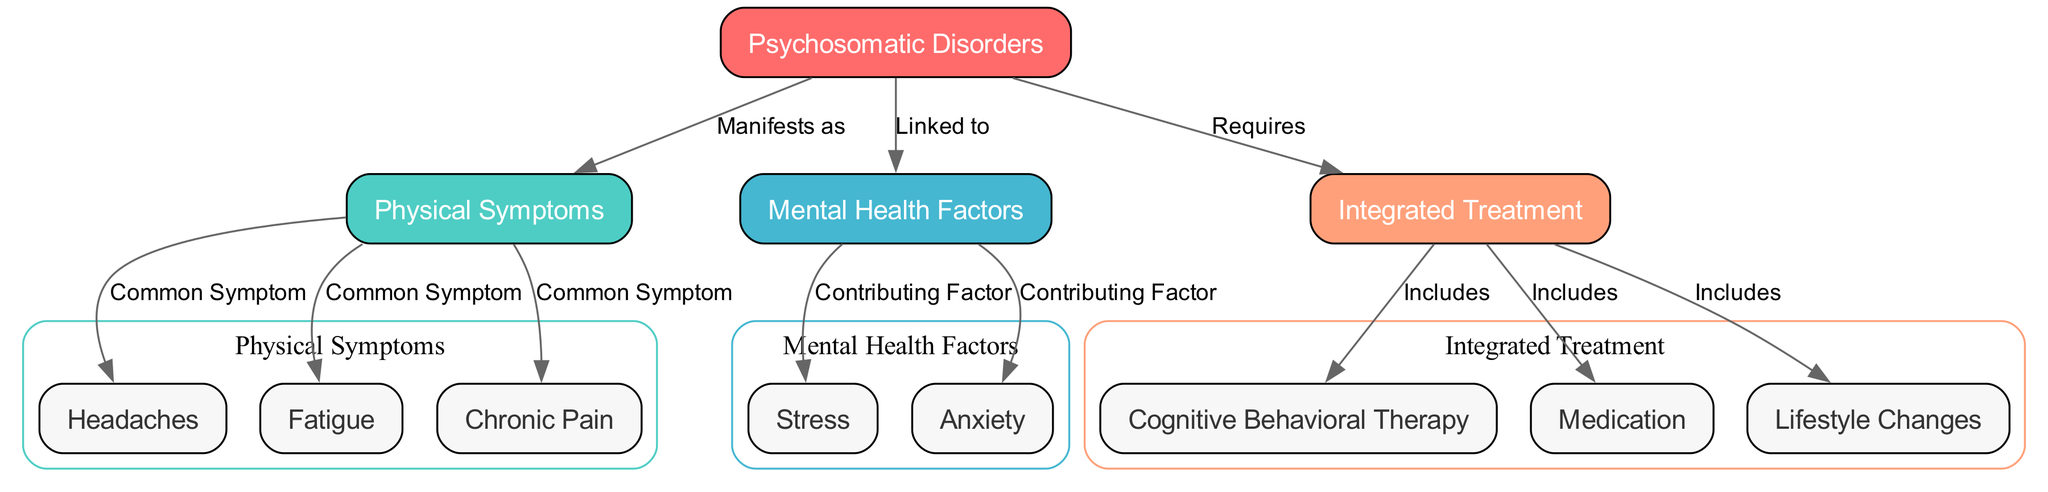What is the main topic of this diagram? The main topic of the diagram is visually represented by the first node labeled 'Psychosomatic Disorders,' indicating that all information relates back to this central theme.
Answer: Psychosomatic Disorders How many common physical symptoms are listed in the diagram? There are three specific physical symptoms listed under the Physical Symptoms cluster: 'Headaches,' 'Fatigue,' and 'Chronic Pain,' which shows the diversity of symptoms that can manifest.
Answer: 3 What are the two mental health factors that are contributing to psychosomatic disorders? The edges from the 'Mental Health Factors' node point to two specific factors: 'Stress' and 'Anxiety,' indicating these are key contributors identified in the diagram.
Answer: Stress, Anxiety Which treatment strategy is included in the integrated treatment? The 'Integrated Treatment' node includes several strategies, one of which is specifically labeled as 'Cognitive Behavioral Therapy,' indicating its role in addressing psychosomatic disorders.
Answer: Cognitive Behavioral Therapy What is the relationship between psychosomatic disorders and physical symptoms? The relationship is depicted through the edge labeled 'Manifests as,' which indicates that psychosomatic disorders manifest or appear as physical symptoms in individuals.
Answer: Manifests as What color represents mental health factors in the diagram? The mental health factors are represented with a distinct color, which is light blue, visually differentiating them from other clusters in the diagram.
Answer: Light blue Which type of therapy is part of the integrated treatment strategies? The diagram includes 'Cognitive Behavioral Therapy' as one of the types of therapy, directly linking this therapeutic approach to the broader treatment strategy for psychosomatic disorders.
Answer: Cognitive Behavioral Therapy How are physical symptoms linked to psychosomatic disorders? Physical symptoms are shown to stem from psychosomatic disorders, as indicated by the directional edge labeled 'Manifests as,' showing a clear relationship between these two concepts.
Answer: Manifests as What are the three components included in integrated treatment? The integrated treatment comprises 'Cognitive Behavioral Therapy,' 'Medication,' and 'Lifestyle Changes,' revealing the multi-faceted approach required to address these disorders.
Answer: Cognitive Behavioral Therapy, Medication, Lifestyle Changes 